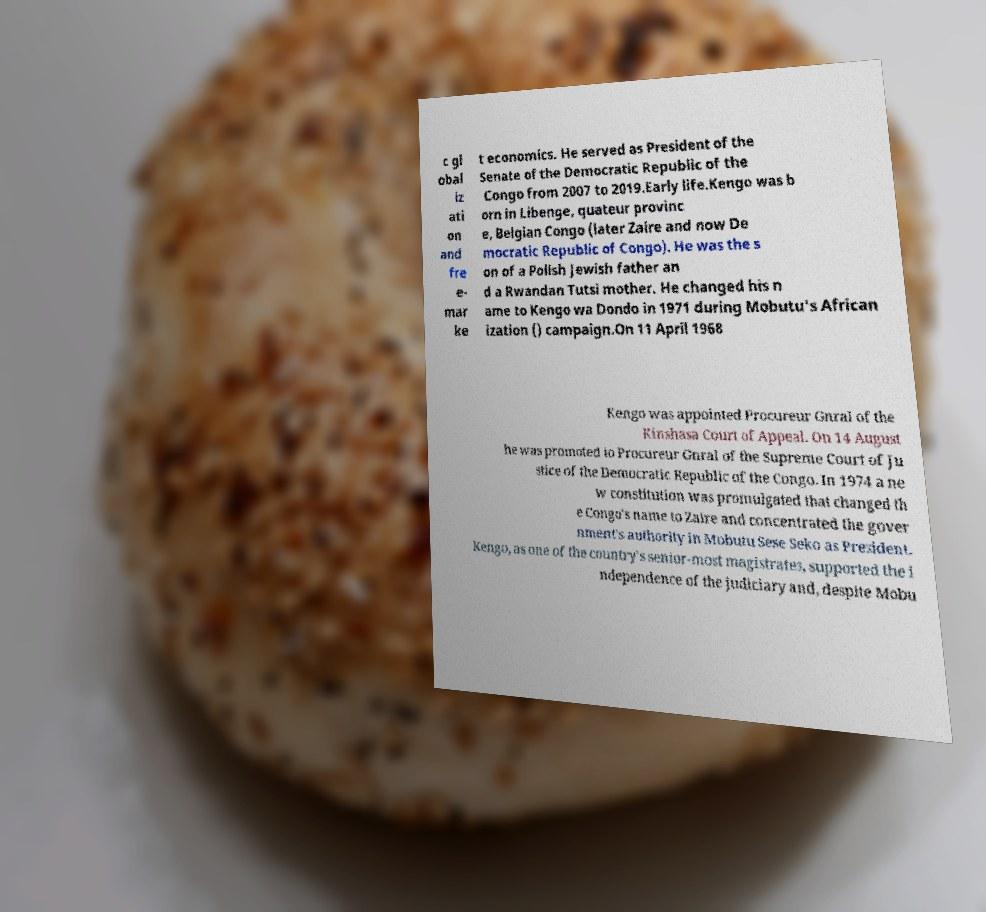Could you extract and type out the text from this image? c gl obal iz ati on and fre e- mar ke t economics. He served as President of the Senate of the Democratic Republic of the Congo from 2007 to 2019.Early life.Kengo was b orn in Libenge, quateur provinc e, Belgian Congo (later Zaire and now De mocratic Republic of Congo). He was the s on of a Polish Jewish father an d a Rwandan Tutsi mother. He changed his n ame to Kengo wa Dondo in 1971 during Mobutu's African ization () campaign.On 11 April 1968 Kengo was appointed Procureur Gnral of the Kinshasa Court of Appeal. On 14 August he was promoted to Procureur Gnral of the Supreme Court of Ju stice of the Democratic Republic of the Congo. In 1974 a ne w constitution was promulgated that changed th e Congo's name to Zaire and concentrated the gover nment's authority in Mobutu Sese Seko as President. Kengo, as one of the country's senior-most magistrates, supported the i ndependence of the judiciary and, despite Mobu 